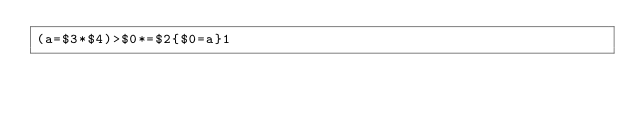<code> <loc_0><loc_0><loc_500><loc_500><_Awk_>(a=$3*$4)>$0*=$2{$0=a}1</code> 